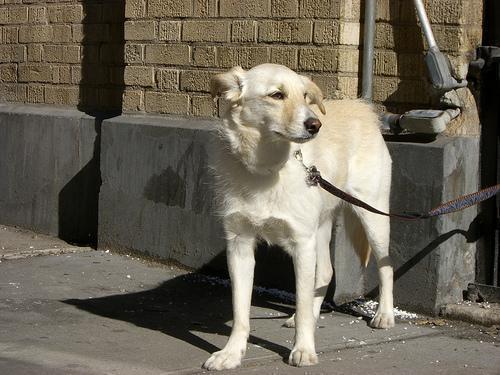How many legs does the dog have?
Give a very brief answer. 4. 